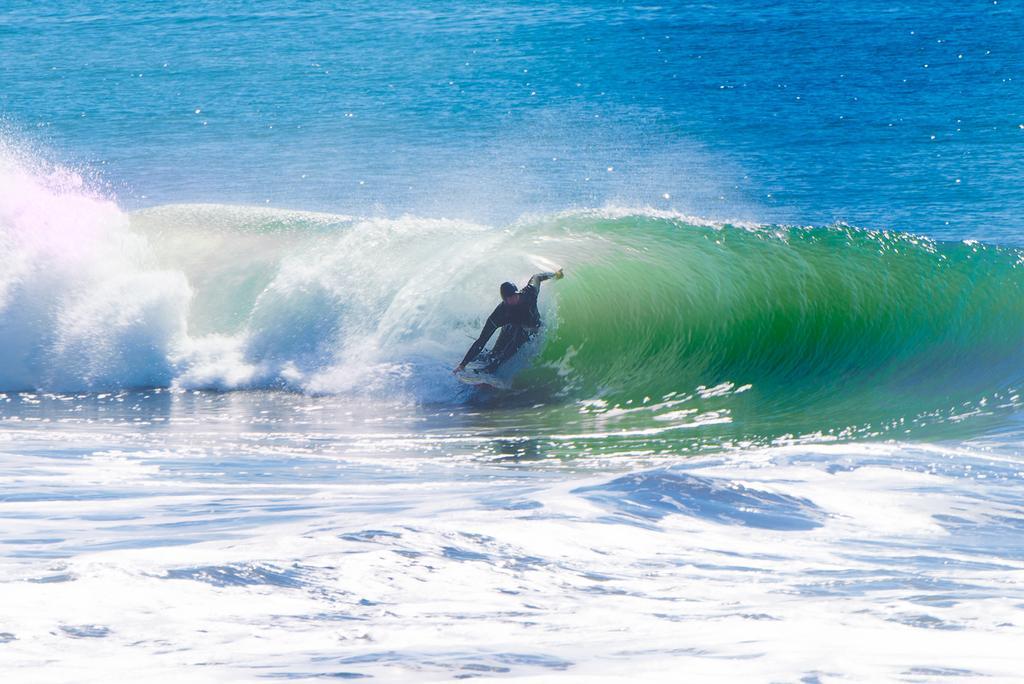In one or two sentences, can you explain what this image depicts? In this picture we can see a person surfing on water with a surfboard. 